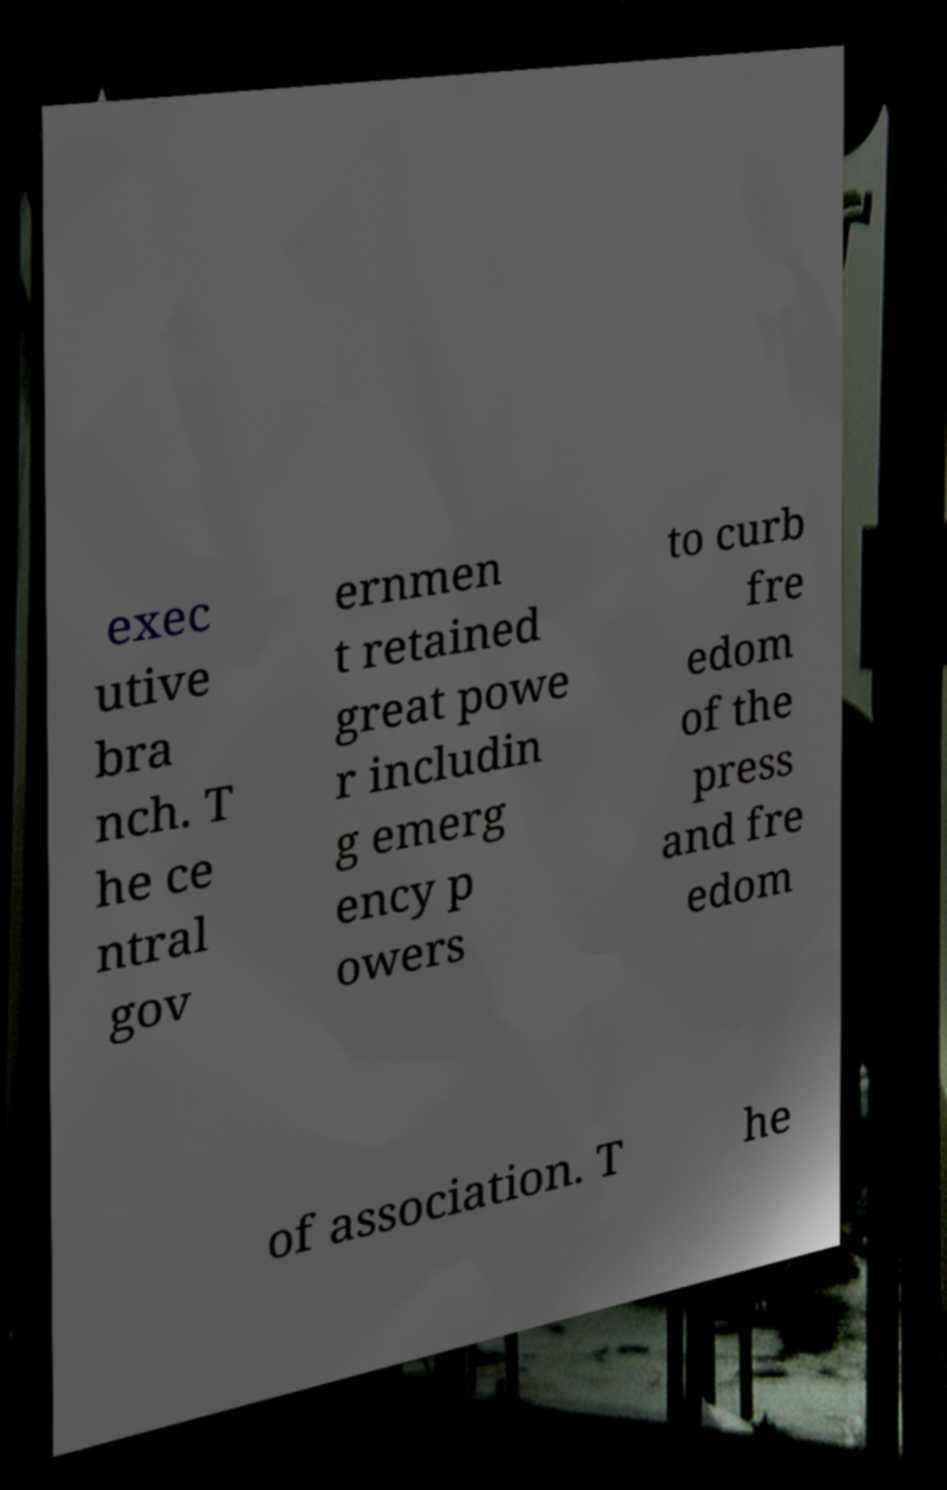For documentation purposes, I need the text within this image transcribed. Could you provide that? exec utive bra nch. T he ce ntral gov ernmen t retained great powe r includin g emerg ency p owers to curb fre edom of the press and fre edom of association. T he 